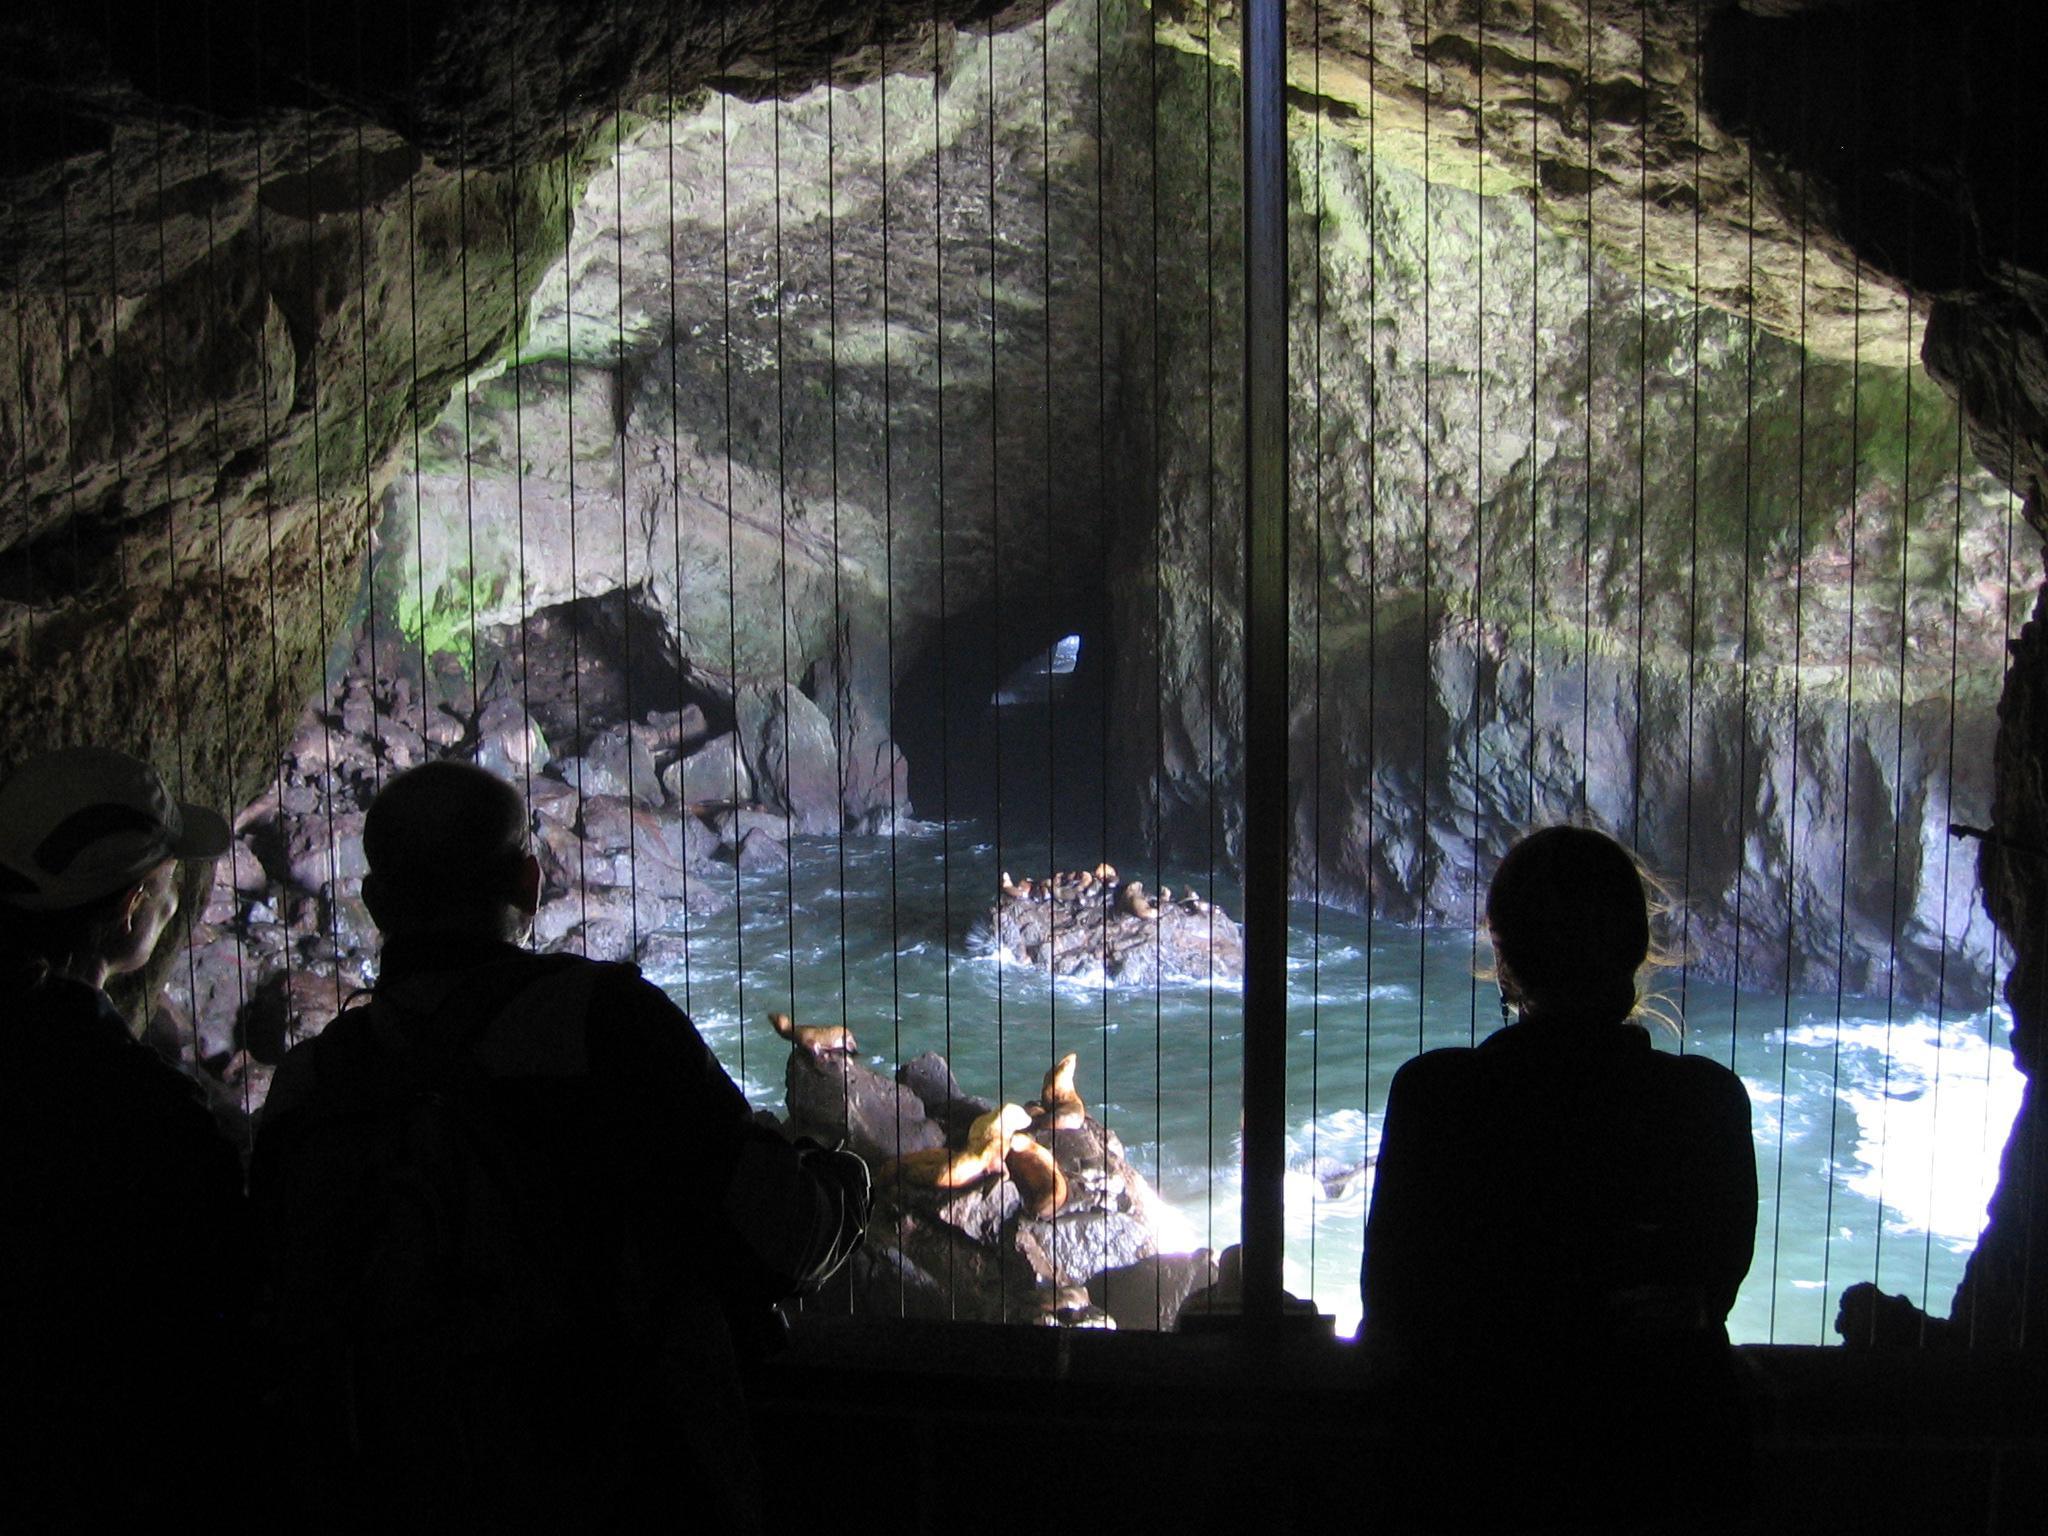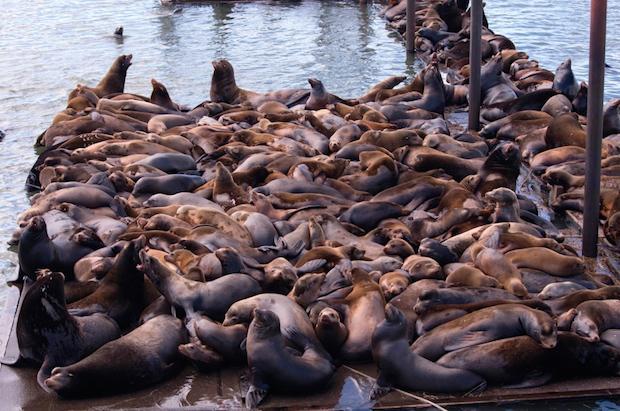The first image is the image on the left, the second image is the image on the right. Assess this claim about the two images: "light spills through a small hole in the cave wall in the image on the right.". Correct or not? Answer yes or no. No. 